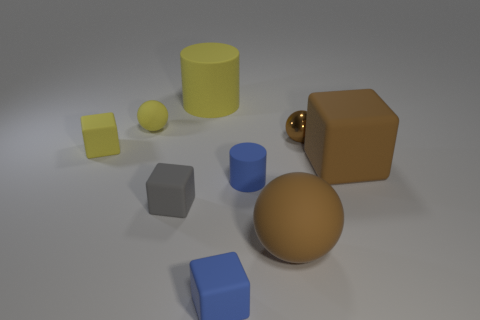Subtract all cubes. How many objects are left? 5 Subtract all spheres. Subtract all big blue shiny cylinders. How many objects are left? 6 Add 1 yellow spheres. How many yellow spheres are left? 2 Add 1 large purple things. How many large purple things exist? 1 Subtract 0 red cylinders. How many objects are left? 9 